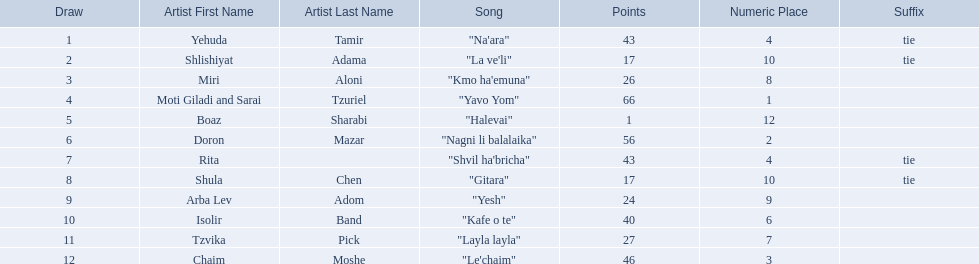How many artists are there? Yehuda Tamir, Shlishiyat Adama, Miri Aloni, Moti Giladi and Sarai Tzuriel, Boaz Sharabi, Doron Mazar, Rita, Shula Chen, Arba Lev Adom, Isolir Band, Tzvika Pick, Chaim Moshe. What is the least amount of points awarded? 1. Who was the artist awarded those points? Boaz Sharabi. 